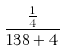<formula> <loc_0><loc_0><loc_500><loc_500>\frac { \frac { 1 } { 4 } } { 1 3 8 + 4 }</formula> 